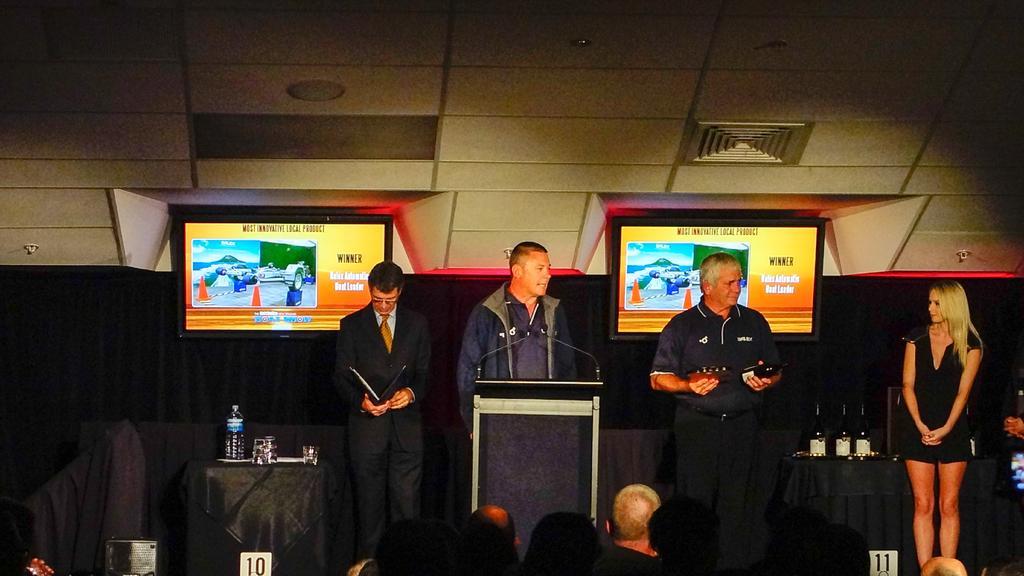Could you give a brief overview of what you see in this image? In this picture I can observe a person standing in front of the podium in the middle of the picture. I can observe two screens behind these members. On the right side I can observe a woman standing. In the background I can observe black color curtain. 